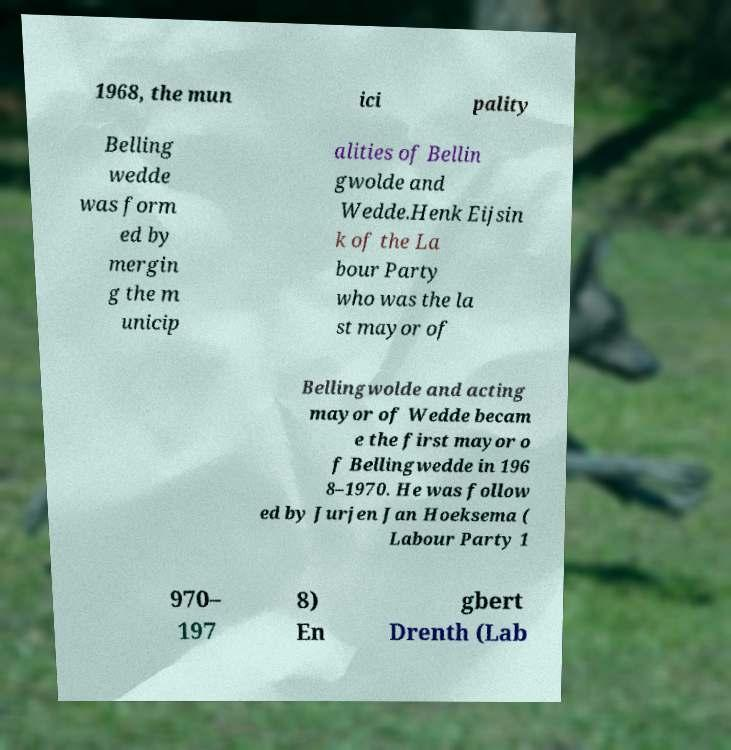What messages or text are displayed in this image? I need them in a readable, typed format. 1968, the mun ici pality Belling wedde was form ed by mergin g the m unicip alities of Bellin gwolde and Wedde.Henk Eijsin k of the La bour Party who was the la st mayor of Bellingwolde and acting mayor of Wedde becam e the first mayor o f Bellingwedde in 196 8–1970. He was follow ed by Jurjen Jan Hoeksema ( Labour Party 1 970– 197 8) En gbert Drenth (Lab 